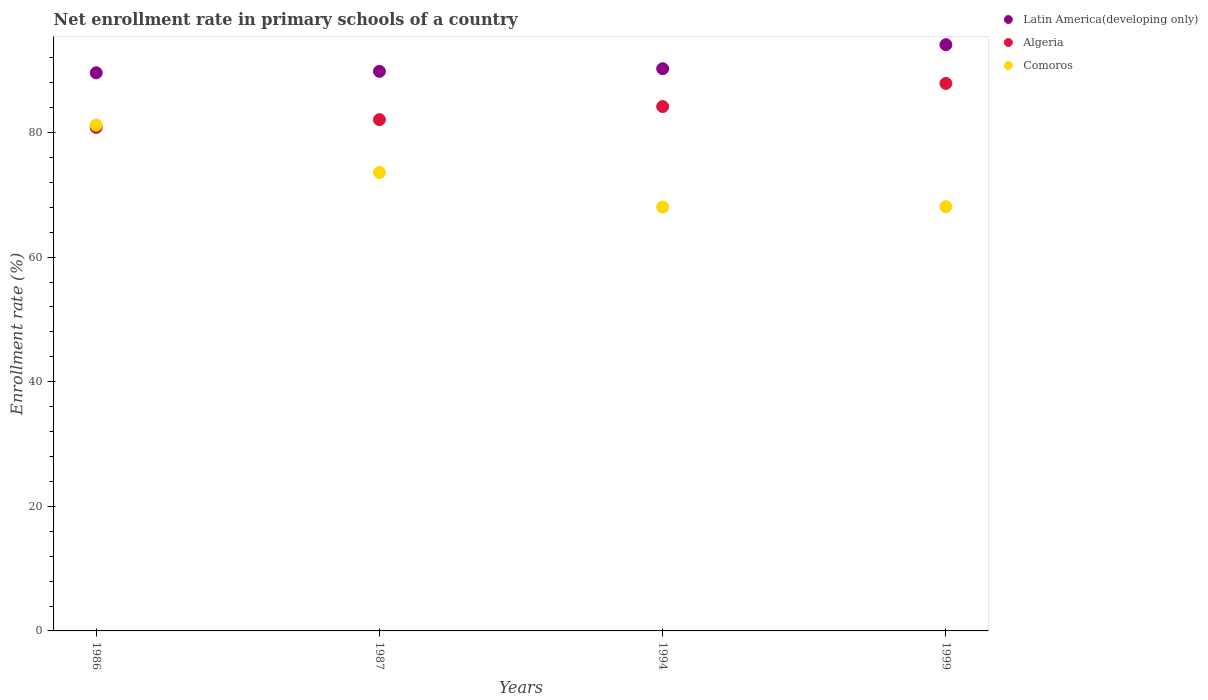Is the number of dotlines equal to the number of legend labels?
Your answer should be compact. Yes. What is the enrollment rate in primary schools in Algeria in 1986?
Keep it short and to the point. 80.81. Across all years, what is the maximum enrollment rate in primary schools in Algeria?
Offer a terse response. 87.88. Across all years, what is the minimum enrollment rate in primary schools in Algeria?
Keep it short and to the point. 80.81. What is the total enrollment rate in primary schools in Algeria in the graph?
Your response must be concise. 334.93. What is the difference between the enrollment rate in primary schools in Latin America(developing only) in 1986 and that in 1987?
Provide a short and direct response. -0.23. What is the difference between the enrollment rate in primary schools in Comoros in 1999 and the enrollment rate in primary schools in Algeria in 1987?
Ensure brevity in your answer.  -13.97. What is the average enrollment rate in primary schools in Comoros per year?
Offer a terse response. 72.73. In the year 1999, what is the difference between the enrollment rate in primary schools in Comoros and enrollment rate in primary schools in Algeria?
Your answer should be compact. -19.78. In how many years, is the enrollment rate in primary schools in Latin America(developing only) greater than 52 %?
Your answer should be very brief. 4. What is the ratio of the enrollment rate in primary schools in Latin America(developing only) in 1986 to that in 1994?
Your response must be concise. 0.99. What is the difference between the highest and the second highest enrollment rate in primary schools in Comoros?
Your answer should be very brief. 7.61. What is the difference between the highest and the lowest enrollment rate in primary schools in Algeria?
Offer a terse response. 7.07. In how many years, is the enrollment rate in primary schools in Algeria greater than the average enrollment rate in primary schools in Algeria taken over all years?
Keep it short and to the point. 2. Is it the case that in every year, the sum of the enrollment rate in primary schools in Algeria and enrollment rate in primary schools in Comoros  is greater than the enrollment rate in primary schools in Latin America(developing only)?
Offer a very short reply. Yes. Does the enrollment rate in primary schools in Latin America(developing only) monotonically increase over the years?
Your answer should be very brief. Yes. What is the difference between two consecutive major ticks on the Y-axis?
Offer a very short reply. 20. Are the values on the major ticks of Y-axis written in scientific E-notation?
Provide a succinct answer. No. Does the graph contain any zero values?
Your response must be concise. No. Does the graph contain grids?
Your response must be concise. No. How many legend labels are there?
Keep it short and to the point. 3. What is the title of the graph?
Your answer should be very brief. Net enrollment rate in primary schools of a country. Does "West Bank and Gaza" appear as one of the legend labels in the graph?
Your answer should be compact. No. What is the label or title of the Y-axis?
Provide a succinct answer. Enrollment rate (%). What is the Enrollment rate (%) of Latin America(developing only) in 1986?
Offer a terse response. 89.59. What is the Enrollment rate (%) of Algeria in 1986?
Offer a terse response. 80.81. What is the Enrollment rate (%) of Comoros in 1986?
Provide a succinct answer. 81.2. What is the Enrollment rate (%) of Latin America(developing only) in 1987?
Provide a succinct answer. 89.82. What is the Enrollment rate (%) in Algeria in 1987?
Ensure brevity in your answer.  82.07. What is the Enrollment rate (%) of Comoros in 1987?
Your response must be concise. 73.58. What is the Enrollment rate (%) of Latin America(developing only) in 1994?
Offer a terse response. 90.24. What is the Enrollment rate (%) in Algeria in 1994?
Give a very brief answer. 84.17. What is the Enrollment rate (%) of Comoros in 1994?
Provide a short and direct response. 68.03. What is the Enrollment rate (%) in Latin America(developing only) in 1999?
Give a very brief answer. 94.1. What is the Enrollment rate (%) of Algeria in 1999?
Your answer should be compact. 87.88. What is the Enrollment rate (%) in Comoros in 1999?
Your response must be concise. 68.1. Across all years, what is the maximum Enrollment rate (%) of Latin America(developing only)?
Keep it short and to the point. 94.1. Across all years, what is the maximum Enrollment rate (%) in Algeria?
Offer a terse response. 87.88. Across all years, what is the maximum Enrollment rate (%) of Comoros?
Give a very brief answer. 81.2. Across all years, what is the minimum Enrollment rate (%) in Latin America(developing only)?
Make the answer very short. 89.59. Across all years, what is the minimum Enrollment rate (%) in Algeria?
Offer a terse response. 80.81. Across all years, what is the minimum Enrollment rate (%) of Comoros?
Your response must be concise. 68.03. What is the total Enrollment rate (%) in Latin America(developing only) in the graph?
Your response must be concise. 363.75. What is the total Enrollment rate (%) of Algeria in the graph?
Offer a terse response. 334.93. What is the total Enrollment rate (%) in Comoros in the graph?
Your answer should be compact. 290.91. What is the difference between the Enrollment rate (%) of Latin America(developing only) in 1986 and that in 1987?
Provide a succinct answer. -0.23. What is the difference between the Enrollment rate (%) in Algeria in 1986 and that in 1987?
Keep it short and to the point. -1.26. What is the difference between the Enrollment rate (%) in Comoros in 1986 and that in 1987?
Offer a very short reply. 7.61. What is the difference between the Enrollment rate (%) in Latin America(developing only) in 1986 and that in 1994?
Make the answer very short. -0.65. What is the difference between the Enrollment rate (%) of Algeria in 1986 and that in 1994?
Keep it short and to the point. -3.35. What is the difference between the Enrollment rate (%) in Comoros in 1986 and that in 1994?
Keep it short and to the point. 13.16. What is the difference between the Enrollment rate (%) of Latin America(developing only) in 1986 and that in 1999?
Provide a succinct answer. -4.51. What is the difference between the Enrollment rate (%) in Algeria in 1986 and that in 1999?
Offer a very short reply. -7.07. What is the difference between the Enrollment rate (%) of Comoros in 1986 and that in 1999?
Your response must be concise. 13.1. What is the difference between the Enrollment rate (%) in Latin America(developing only) in 1987 and that in 1994?
Offer a terse response. -0.42. What is the difference between the Enrollment rate (%) of Algeria in 1987 and that in 1994?
Keep it short and to the point. -2.1. What is the difference between the Enrollment rate (%) in Comoros in 1987 and that in 1994?
Offer a terse response. 5.55. What is the difference between the Enrollment rate (%) in Latin America(developing only) in 1987 and that in 1999?
Your answer should be very brief. -4.28. What is the difference between the Enrollment rate (%) of Algeria in 1987 and that in 1999?
Your answer should be very brief. -5.81. What is the difference between the Enrollment rate (%) of Comoros in 1987 and that in 1999?
Ensure brevity in your answer.  5.48. What is the difference between the Enrollment rate (%) in Latin America(developing only) in 1994 and that in 1999?
Keep it short and to the point. -3.86. What is the difference between the Enrollment rate (%) in Algeria in 1994 and that in 1999?
Your answer should be very brief. -3.72. What is the difference between the Enrollment rate (%) in Comoros in 1994 and that in 1999?
Provide a short and direct response. -0.07. What is the difference between the Enrollment rate (%) in Latin America(developing only) in 1986 and the Enrollment rate (%) in Algeria in 1987?
Your answer should be very brief. 7.52. What is the difference between the Enrollment rate (%) of Latin America(developing only) in 1986 and the Enrollment rate (%) of Comoros in 1987?
Keep it short and to the point. 16.01. What is the difference between the Enrollment rate (%) of Algeria in 1986 and the Enrollment rate (%) of Comoros in 1987?
Your answer should be very brief. 7.23. What is the difference between the Enrollment rate (%) of Latin America(developing only) in 1986 and the Enrollment rate (%) of Algeria in 1994?
Make the answer very short. 5.42. What is the difference between the Enrollment rate (%) in Latin America(developing only) in 1986 and the Enrollment rate (%) in Comoros in 1994?
Ensure brevity in your answer.  21.56. What is the difference between the Enrollment rate (%) in Algeria in 1986 and the Enrollment rate (%) in Comoros in 1994?
Your answer should be compact. 12.78. What is the difference between the Enrollment rate (%) in Latin America(developing only) in 1986 and the Enrollment rate (%) in Algeria in 1999?
Keep it short and to the point. 1.71. What is the difference between the Enrollment rate (%) of Latin America(developing only) in 1986 and the Enrollment rate (%) of Comoros in 1999?
Your response must be concise. 21.49. What is the difference between the Enrollment rate (%) of Algeria in 1986 and the Enrollment rate (%) of Comoros in 1999?
Provide a short and direct response. 12.71. What is the difference between the Enrollment rate (%) of Latin America(developing only) in 1987 and the Enrollment rate (%) of Algeria in 1994?
Ensure brevity in your answer.  5.65. What is the difference between the Enrollment rate (%) in Latin America(developing only) in 1987 and the Enrollment rate (%) in Comoros in 1994?
Provide a short and direct response. 21.79. What is the difference between the Enrollment rate (%) in Algeria in 1987 and the Enrollment rate (%) in Comoros in 1994?
Ensure brevity in your answer.  14.04. What is the difference between the Enrollment rate (%) in Latin America(developing only) in 1987 and the Enrollment rate (%) in Algeria in 1999?
Provide a short and direct response. 1.94. What is the difference between the Enrollment rate (%) of Latin America(developing only) in 1987 and the Enrollment rate (%) of Comoros in 1999?
Offer a terse response. 21.72. What is the difference between the Enrollment rate (%) of Algeria in 1987 and the Enrollment rate (%) of Comoros in 1999?
Provide a short and direct response. 13.97. What is the difference between the Enrollment rate (%) in Latin America(developing only) in 1994 and the Enrollment rate (%) in Algeria in 1999?
Give a very brief answer. 2.36. What is the difference between the Enrollment rate (%) in Latin America(developing only) in 1994 and the Enrollment rate (%) in Comoros in 1999?
Offer a terse response. 22.14. What is the difference between the Enrollment rate (%) in Algeria in 1994 and the Enrollment rate (%) in Comoros in 1999?
Give a very brief answer. 16.07. What is the average Enrollment rate (%) of Latin America(developing only) per year?
Ensure brevity in your answer.  90.94. What is the average Enrollment rate (%) in Algeria per year?
Ensure brevity in your answer.  83.73. What is the average Enrollment rate (%) of Comoros per year?
Your answer should be compact. 72.73. In the year 1986, what is the difference between the Enrollment rate (%) of Latin America(developing only) and Enrollment rate (%) of Algeria?
Give a very brief answer. 8.78. In the year 1986, what is the difference between the Enrollment rate (%) in Latin America(developing only) and Enrollment rate (%) in Comoros?
Provide a succinct answer. 8.39. In the year 1986, what is the difference between the Enrollment rate (%) of Algeria and Enrollment rate (%) of Comoros?
Offer a very short reply. -0.38. In the year 1987, what is the difference between the Enrollment rate (%) in Latin America(developing only) and Enrollment rate (%) in Algeria?
Provide a short and direct response. 7.75. In the year 1987, what is the difference between the Enrollment rate (%) in Latin America(developing only) and Enrollment rate (%) in Comoros?
Your answer should be very brief. 16.23. In the year 1987, what is the difference between the Enrollment rate (%) of Algeria and Enrollment rate (%) of Comoros?
Ensure brevity in your answer.  8.49. In the year 1994, what is the difference between the Enrollment rate (%) in Latin America(developing only) and Enrollment rate (%) in Algeria?
Keep it short and to the point. 6.07. In the year 1994, what is the difference between the Enrollment rate (%) of Latin America(developing only) and Enrollment rate (%) of Comoros?
Give a very brief answer. 22.21. In the year 1994, what is the difference between the Enrollment rate (%) of Algeria and Enrollment rate (%) of Comoros?
Your response must be concise. 16.14. In the year 1999, what is the difference between the Enrollment rate (%) of Latin America(developing only) and Enrollment rate (%) of Algeria?
Provide a succinct answer. 6.22. In the year 1999, what is the difference between the Enrollment rate (%) of Latin America(developing only) and Enrollment rate (%) of Comoros?
Your response must be concise. 26. In the year 1999, what is the difference between the Enrollment rate (%) in Algeria and Enrollment rate (%) in Comoros?
Your answer should be very brief. 19.78. What is the ratio of the Enrollment rate (%) in Latin America(developing only) in 1986 to that in 1987?
Offer a very short reply. 1. What is the ratio of the Enrollment rate (%) in Algeria in 1986 to that in 1987?
Offer a very short reply. 0.98. What is the ratio of the Enrollment rate (%) of Comoros in 1986 to that in 1987?
Ensure brevity in your answer.  1.1. What is the ratio of the Enrollment rate (%) in Latin America(developing only) in 1986 to that in 1994?
Offer a terse response. 0.99. What is the ratio of the Enrollment rate (%) in Algeria in 1986 to that in 1994?
Keep it short and to the point. 0.96. What is the ratio of the Enrollment rate (%) of Comoros in 1986 to that in 1994?
Keep it short and to the point. 1.19. What is the ratio of the Enrollment rate (%) in Latin America(developing only) in 1986 to that in 1999?
Your answer should be compact. 0.95. What is the ratio of the Enrollment rate (%) of Algeria in 1986 to that in 1999?
Provide a short and direct response. 0.92. What is the ratio of the Enrollment rate (%) of Comoros in 1986 to that in 1999?
Provide a short and direct response. 1.19. What is the ratio of the Enrollment rate (%) of Algeria in 1987 to that in 1994?
Provide a short and direct response. 0.98. What is the ratio of the Enrollment rate (%) in Comoros in 1987 to that in 1994?
Offer a very short reply. 1.08. What is the ratio of the Enrollment rate (%) of Latin America(developing only) in 1987 to that in 1999?
Give a very brief answer. 0.95. What is the ratio of the Enrollment rate (%) of Algeria in 1987 to that in 1999?
Ensure brevity in your answer.  0.93. What is the ratio of the Enrollment rate (%) of Comoros in 1987 to that in 1999?
Provide a succinct answer. 1.08. What is the ratio of the Enrollment rate (%) in Latin America(developing only) in 1994 to that in 1999?
Give a very brief answer. 0.96. What is the ratio of the Enrollment rate (%) in Algeria in 1994 to that in 1999?
Your response must be concise. 0.96. What is the ratio of the Enrollment rate (%) of Comoros in 1994 to that in 1999?
Make the answer very short. 1. What is the difference between the highest and the second highest Enrollment rate (%) of Latin America(developing only)?
Offer a very short reply. 3.86. What is the difference between the highest and the second highest Enrollment rate (%) in Algeria?
Ensure brevity in your answer.  3.72. What is the difference between the highest and the second highest Enrollment rate (%) of Comoros?
Give a very brief answer. 7.61. What is the difference between the highest and the lowest Enrollment rate (%) of Latin America(developing only)?
Offer a very short reply. 4.51. What is the difference between the highest and the lowest Enrollment rate (%) in Algeria?
Provide a short and direct response. 7.07. What is the difference between the highest and the lowest Enrollment rate (%) of Comoros?
Ensure brevity in your answer.  13.16. 